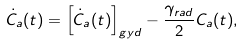Convert formula to latex. <formula><loc_0><loc_0><loc_500><loc_500>\dot { C } _ { a } ( t ) = \left [ \dot { C } _ { a } ( t ) \right ] _ { g y d } - \frac { \gamma _ { r a d } } { 2 } C _ { a } ( t ) ,</formula> 